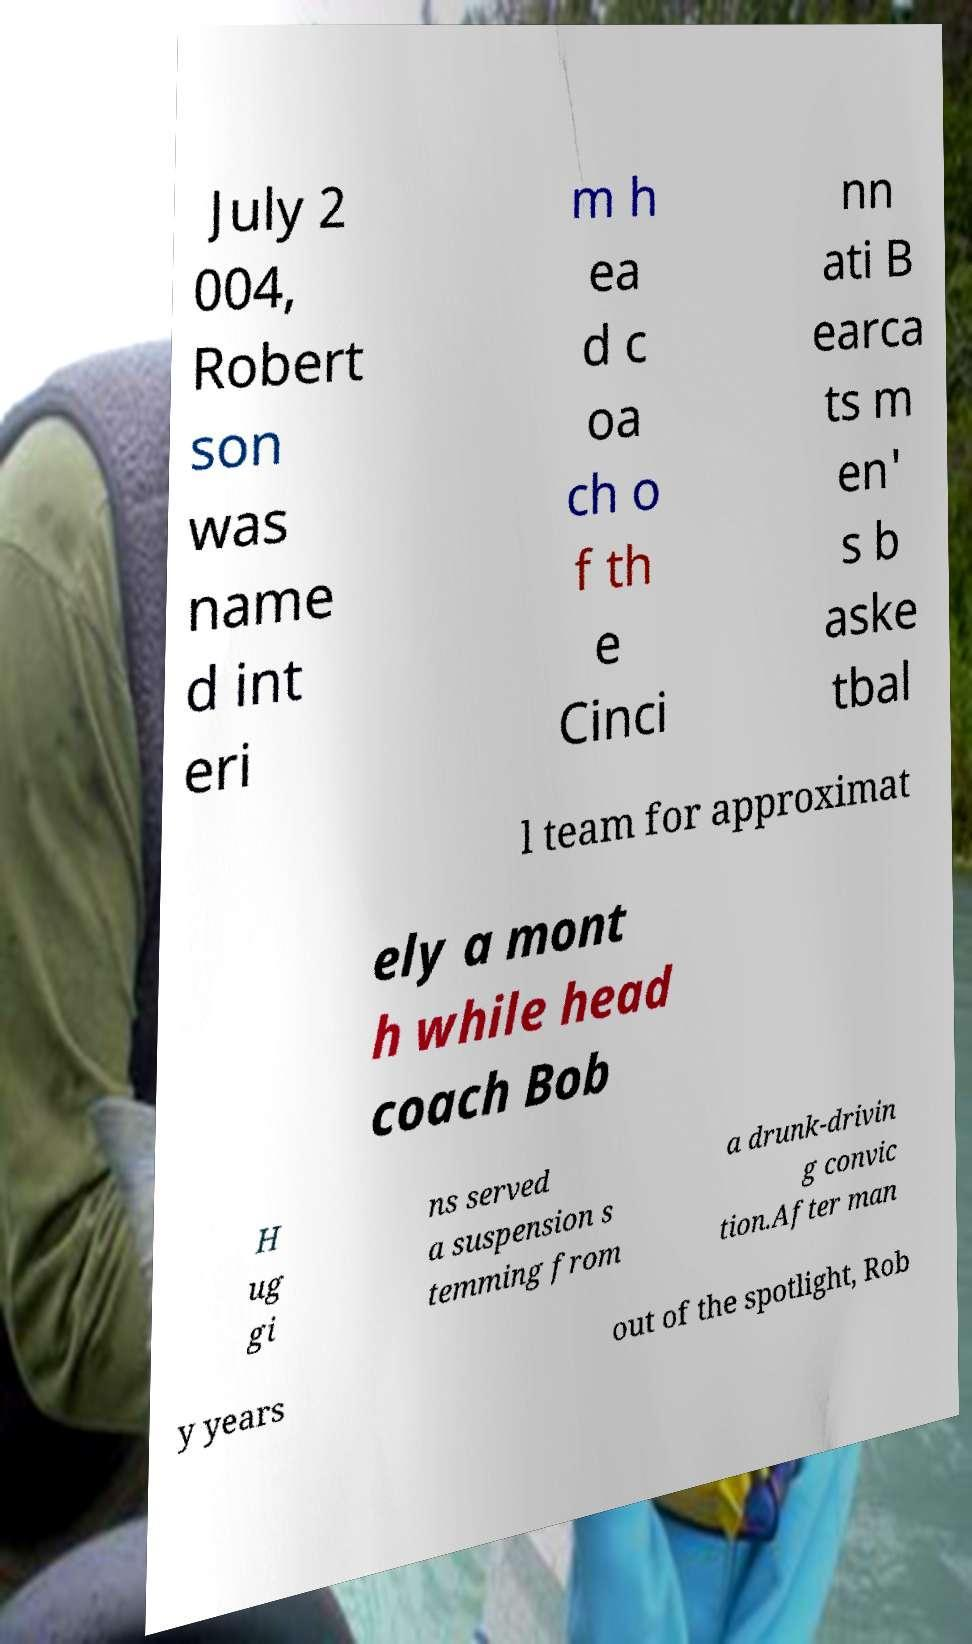Please identify and transcribe the text found in this image. July 2 004, Robert son was name d int eri m h ea d c oa ch o f th e Cinci nn ati B earca ts m en' s b aske tbal l team for approximat ely a mont h while head coach Bob H ug gi ns served a suspension s temming from a drunk-drivin g convic tion.After man y years out of the spotlight, Rob 